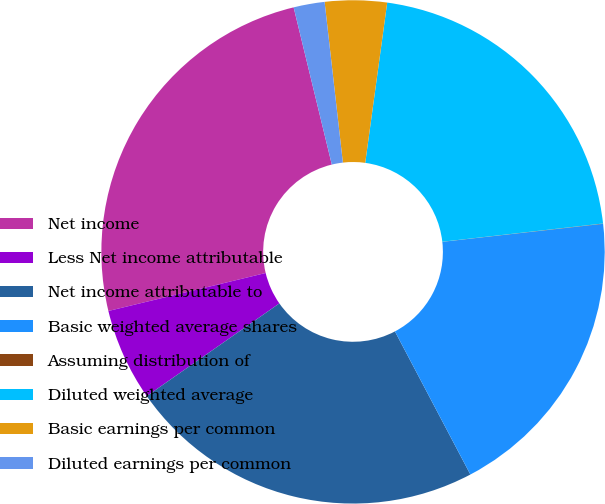<chart> <loc_0><loc_0><loc_500><loc_500><pie_chart><fcel>Net income<fcel>Less Net income attributable<fcel>Net income attributable to<fcel>Basic weighted average shares<fcel>Assuming distribution of<fcel>Diluted weighted average<fcel>Basic earnings per common<fcel>Diluted earnings per common<nl><fcel>24.98%<fcel>5.94%<fcel>23.01%<fcel>19.06%<fcel>0.02%<fcel>21.03%<fcel>3.97%<fcel>1.99%<nl></chart> 